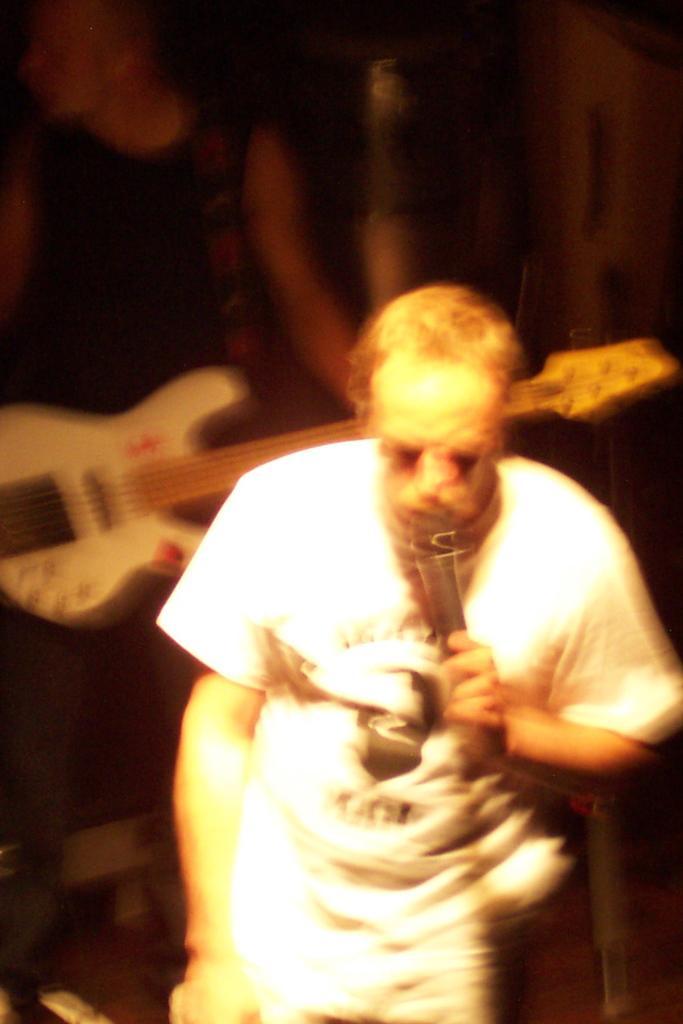Could you give a brief overview of what you see in this image? One person wearing a white dress is holding a mic and talking. Behind him another person wearing black dress is holding a guitar. 